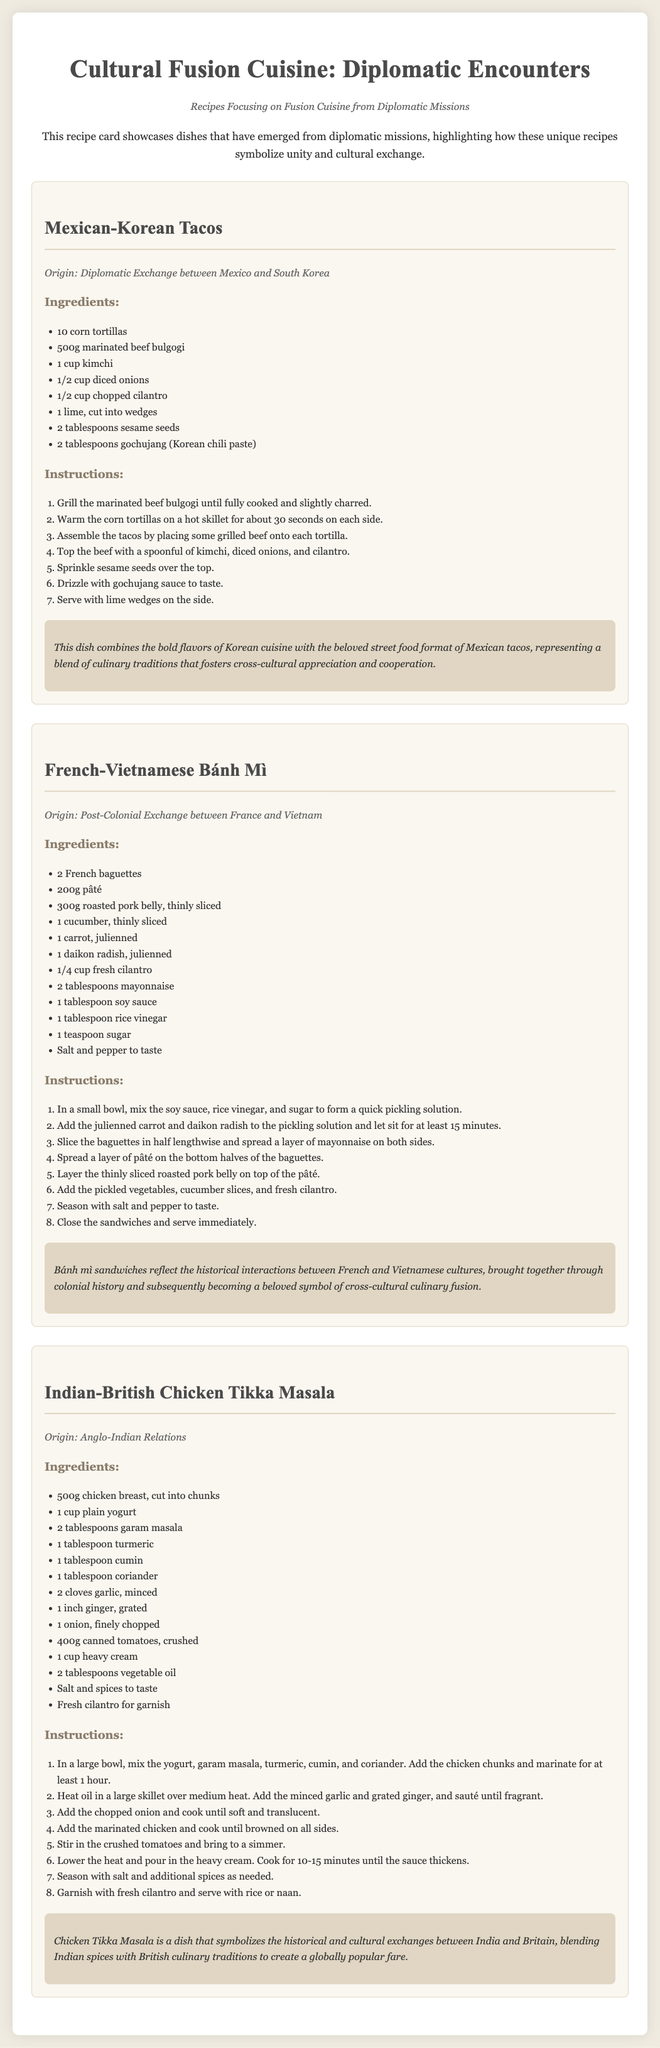What are the main ingredients of Mexican-Korean tacos? The ingredients listed for Mexican-Korean tacos include marinated beef bulgogi, corn tortillas, kimchi, diced onions, chopped cilantro, lime, sesame seeds, and gochujang.
Answer: marinated beef bulgogi, corn tortillas, kimchi, diced onions, chopped cilantro, lime, sesame seeds, gochujang What is the origin of the French-Vietnamese Bánh Mì? The document states that the origin of the French-Vietnamese Bánh Mì is from post-colonial exchanges between France and Vietnam.
Answer: Post-Colonial Exchange between France and Vietnam How many corn tortillas are needed for the Mexican-Korean tacos? The recipe specifies that 10 corn tortillas are required for the Mexican-Korean tacos.
Answer: 10 What does the symbolism of the Indian-British Chicken Tikka Masala represent? The symbolism paragraph indicates that Chicken Tikka Masala represents the historical and cultural exchanges between India and Britain, blending their culinary traditions.
Answer: Historical and cultural exchanges between India and Britain How long should the carrots and daikon radish sit in the pickling solution for Bánh Mì? The instructions mention that the carrots and daikon radish should sit in the pickling solution for at least 15 minutes.
Answer: At least 15 minutes What cooking method is used for beef bulgogi in the Mexican-Korean tacos? The instructions note that the marinated beef bulgogi should be grilled until fully cooked and slightly charred.
Answer: Grilled What is the total number of dishes mentioned in the document? The document features a total of three dishes: Mexican-Korean Tacos, French-Vietnamese Bánh Mì, and Indian-British Chicken Tikka Masala.
Answer: Three What is included in the serving of Mexican-Korean tacos on the side? The recipe specifies serving lime wedges on the side with the Mexican-Korean tacos.
Answer: Lime wedges 